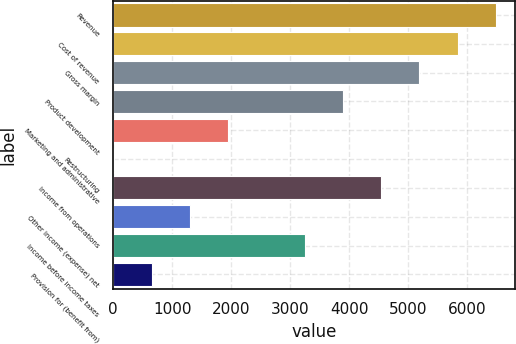Convert chart. <chart><loc_0><loc_0><loc_500><loc_500><bar_chart><fcel>Revenue<fcel>Cost of revenue<fcel>Gross margin<fcel>Product development<fcel>Marketing and administrative<fcel>Restructuring<fcel>Income from operations<fcel>Other income (expense) net<fcel>Income before income taxes<fcel>Provision for (benefit from)<nl><fcel>6486<fcel>5838.3<fcel>5190.6<fcel>3895.2<fcel>1952.1<fcel>9<fcel>4542.9<fcel>1304.4<fcel>3247.5<fcel>656.7<nl></chart> 